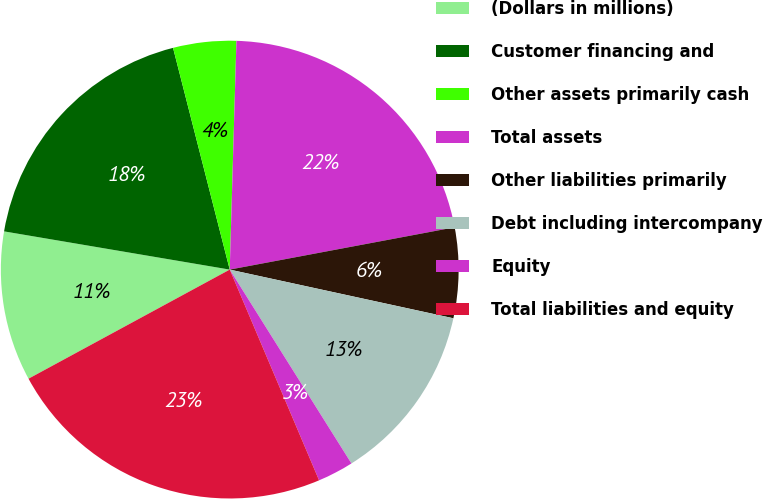Convert chart to OTSL. <chart><loc_0><loc_0><loc_500><loc_500><pie_chart><fcel>(Dollars in millions)<fcel>Customer financing and<fcel>Other assets primarily cash<fcel>Total assets<fcel>Other liabilities primarily<fcel>Debt including intercompany<fcel>Equity<fcel>Total liabilities and equity<nl><fcel>10.58%<fcel>18.35%<fcel>4.45%<fcel>21.58%<fcel>6.37%<fcel>12.67%<fcel>2.54%<fcel>23.48%<nl></chart> 